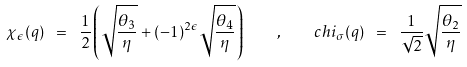<formula> <loc_0><loc_0><loc_500><loc_500>\chi _ { \epsilon } ( q ) \ = \ \frac { 1 } { 2 } \left ( \sqrt { \frac { \theta _ { 3 } } { \eta } } + ( - 1 ) ^ { 2 \epsilon } \sqrt { \frac { \theta _ { 4 } } { \eta } } \right ) \quad , \quad c h i _ { \sigma } ( q ) \ = \ \frac { 1 } { \sqrt { 2 } } \sqrt { \frac { \theta _ { 2 } } { \eta } }</formula> 